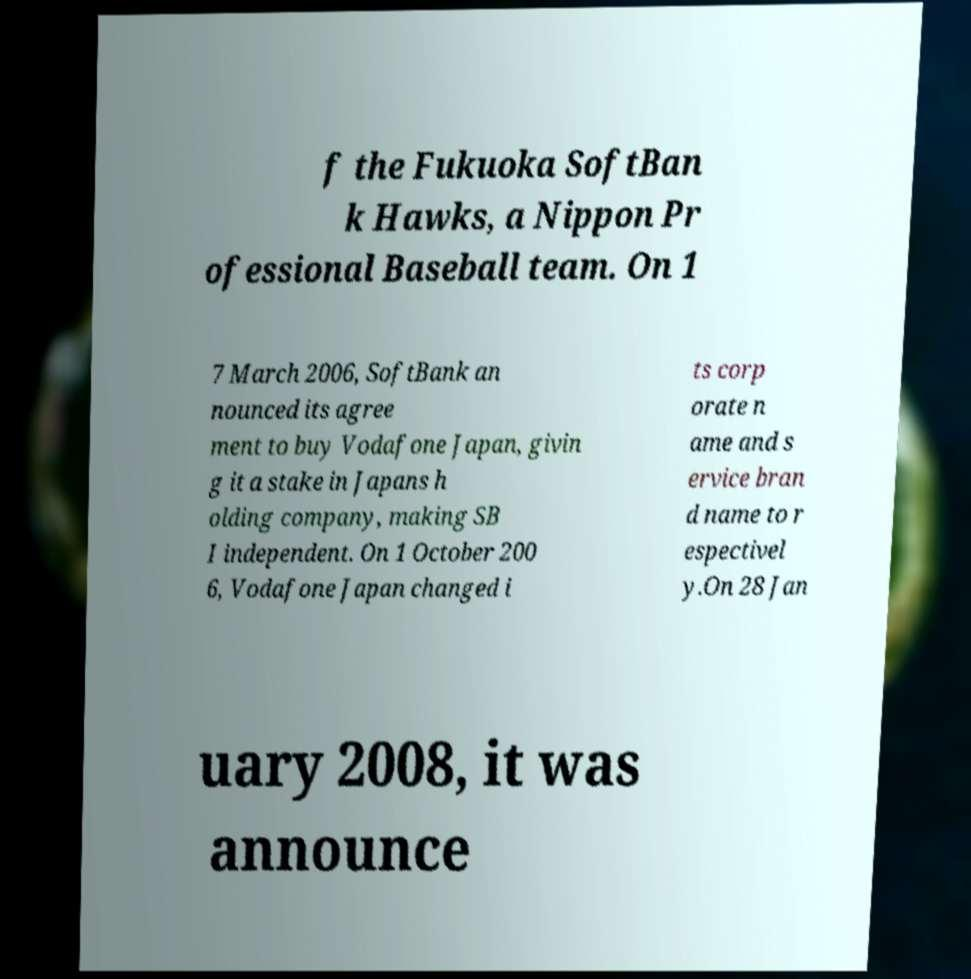Please identify and transcribe the text found in this image. f the Fukuoka SoftBan k Hawks, a Nippon Pr ofessional Baseball team. On 1 7 March 2006, SoftBank an nounced its agree ment to buy Vodafone Japan, givin g it a stake in Japans h olding company, making SB I independent. On 1 October 200 6, Vodafone Japan changed i ts corp orate n ame and s ervice bran d name to r espectivel y.On 28 Jan uary 2008, it was announce 